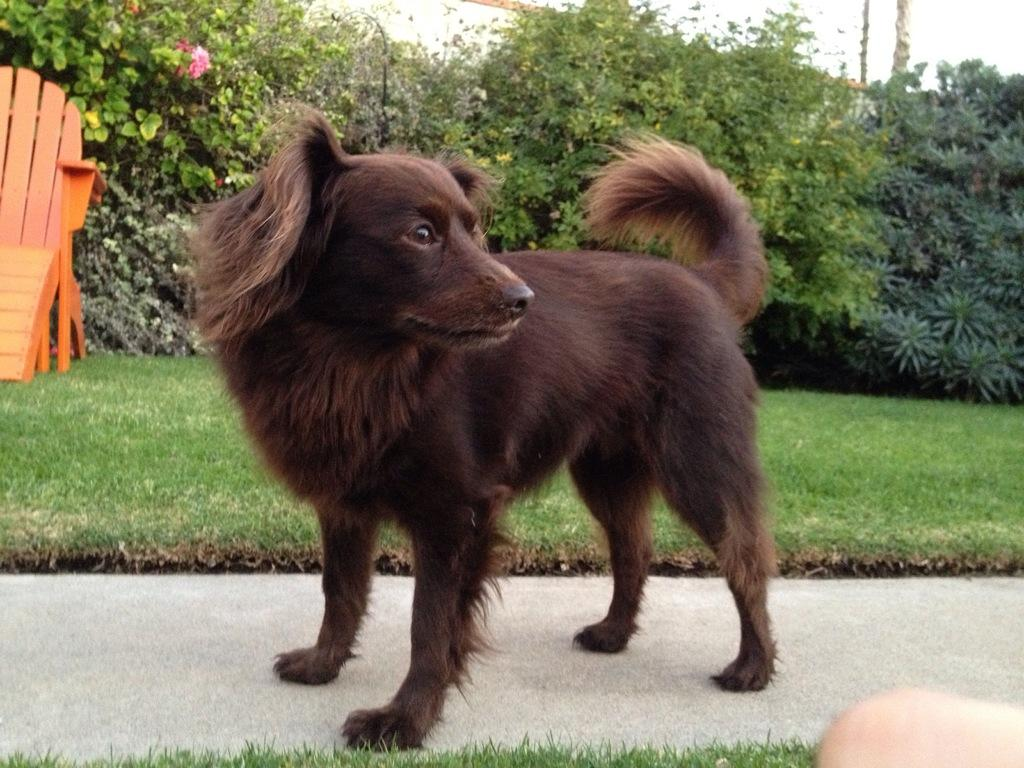What type of animal is in the image? There is a dog in the image. What can be seen in the background of the image? There is a wooden object, flowers, plants, and grass in the background of the image. What riddle does the dog solve in the image? There is no riddle in the image, nor does the dog solve one. 